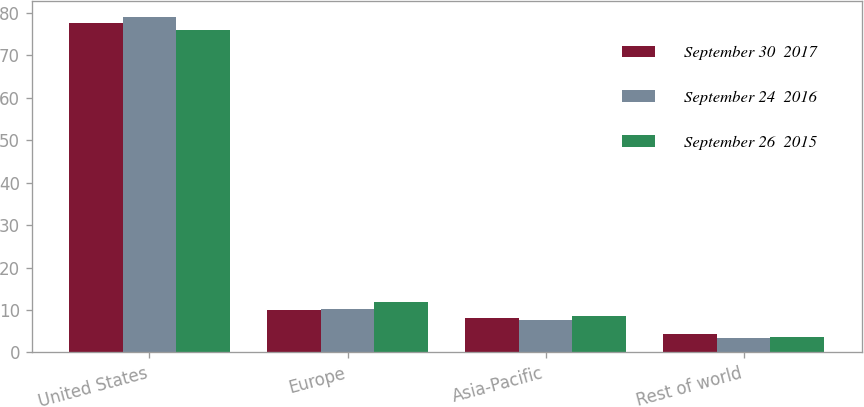Convert chart. <chart><loc_0><loc_0><loc_500><loc_500><stacked_bar_chart><ecel><fcel>United States<fcel>Europe<fcel>Asia-Pacific<fcel>Rest of world<nl><fcel>September 30  2017<fcel>77.6<fcel>10<fcel>8.1<fcel>4.3<nl><fcel>September 24  2016<fcel>78.9<fcel>10.2<fcel>7.6<fcel>3.3<nl><fcel>September 26  2015<fcel>76<fcel>11.8<fcel>8.5<fcel>3.7<nl></chart> 